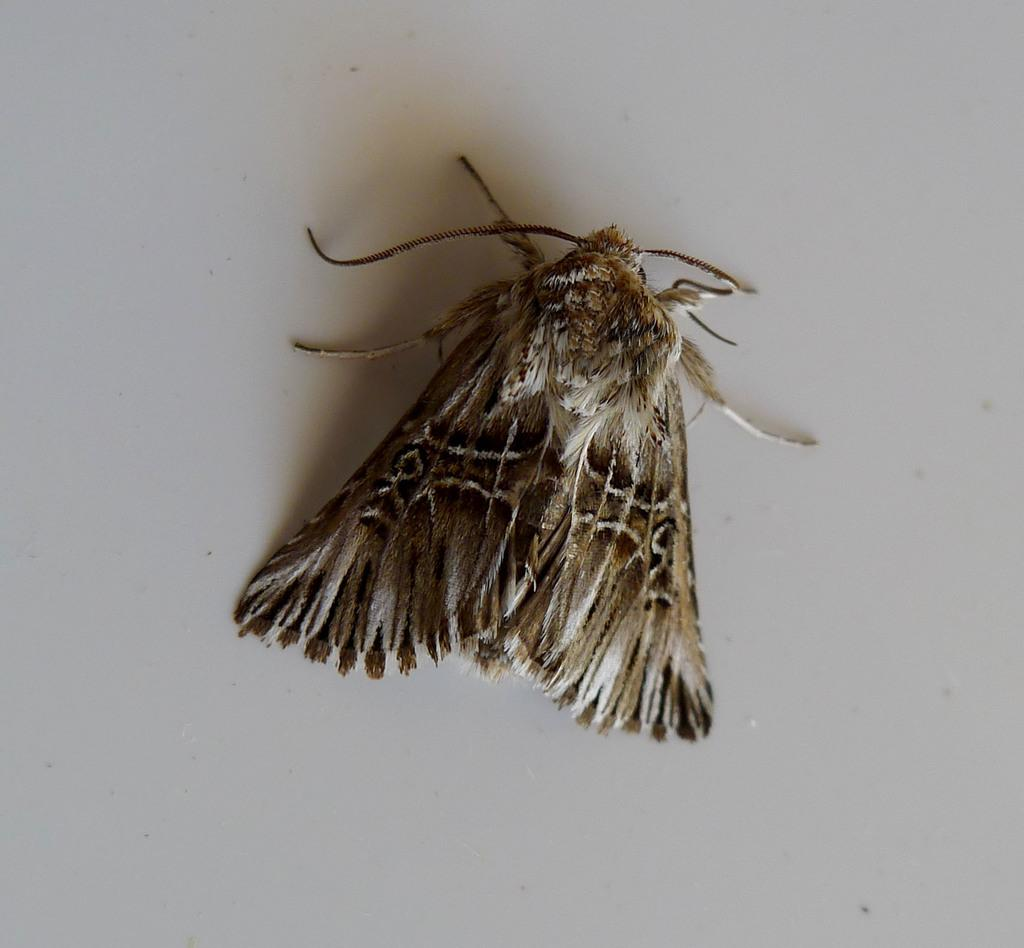What type of creature is in the image? There is an insect in the image. Where is the insect located in the image? The insect is on a path. What is the insect's limit in terms of its ability to travel to different nations? The image does not provide information about the insect's ability to travel to different nations, nor does it show any nations. 